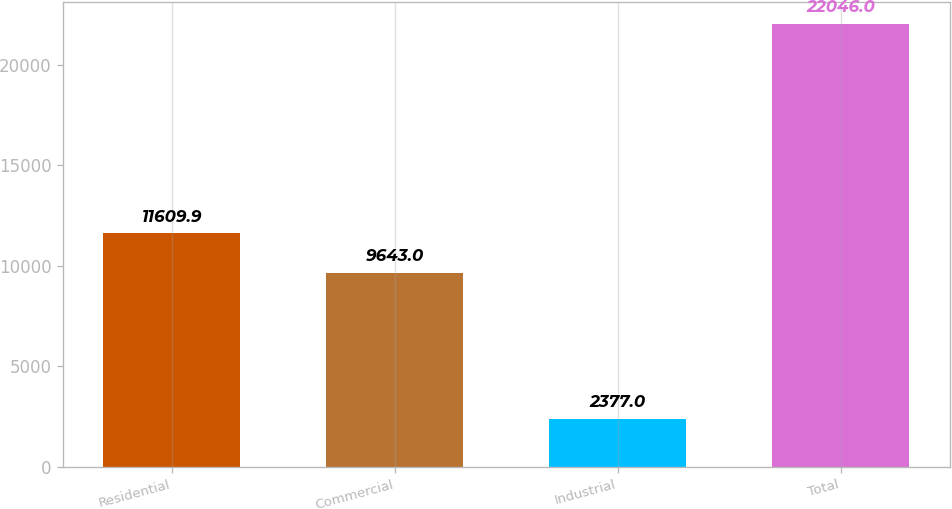Convert chart to OTSL. <chart><loc_0><loc_0><loc_500><loc_500><bar_chart><fcel>Residential<fcel>Commercial<fcel>Industrial<fcel>Total<nl><fcel>11609.9<fcel>9643<fcel>2377<fcel>22046<nl></chart> 